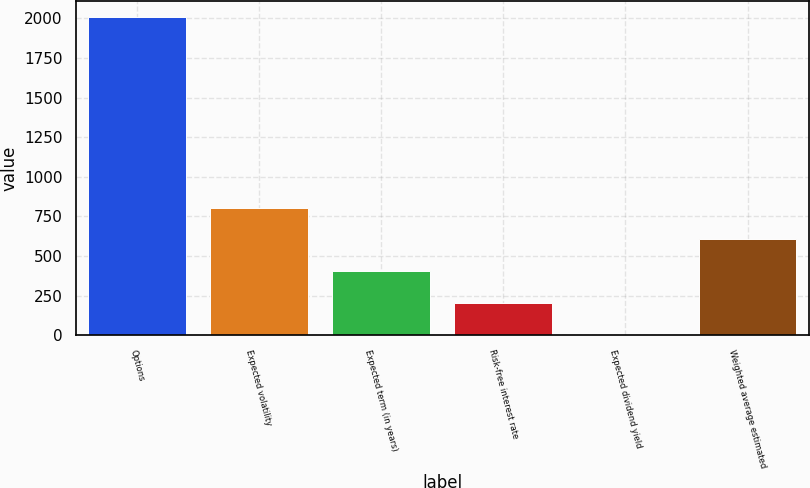Convert chart. <chart><loc_0><loc_0><loc_500><loc_500><bar_chart><fcel>Options<fcel>Expected volatility<fcel>Expected term (in years)<fcel>Risk-free interest rate<fcel>Expected dividend yield<fcel>Weighted average estimated<nl><fcel>2011<fcel>805.36<fcel>403.48<fcel>202.54<fcel>1.6<fcel>604.42<nl></chart> 